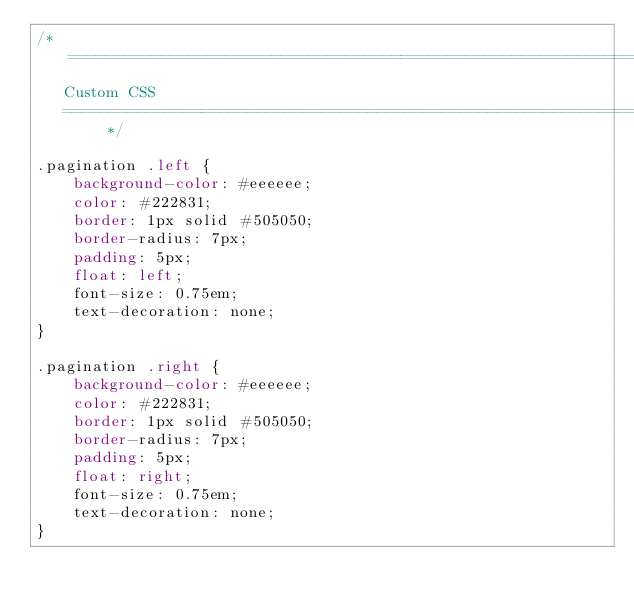Convert code to text. <code><loc_0><loc_0><loc_500><loc_500><_CSS_>/* ==========================================================================
   Custom CSS
   ========================================================================== */

.pagination .left {
    background-color: #eeeeee;
    color: #222831;
    border: 1px solid #505050;
    border-radius: 7px;
    padding: 5px;
    float: left;
    font-size: 0.75em;
    text-decoration: none;
}

.pagination .right {
    background-color: #eeeeee;
    color: #222831;
    border: 1px solid #505050;
    border-radius: 7px;
    padding: 5px;
    float: right;
    font-size: 0.75em;
    text-decoration: none;
}</code> 